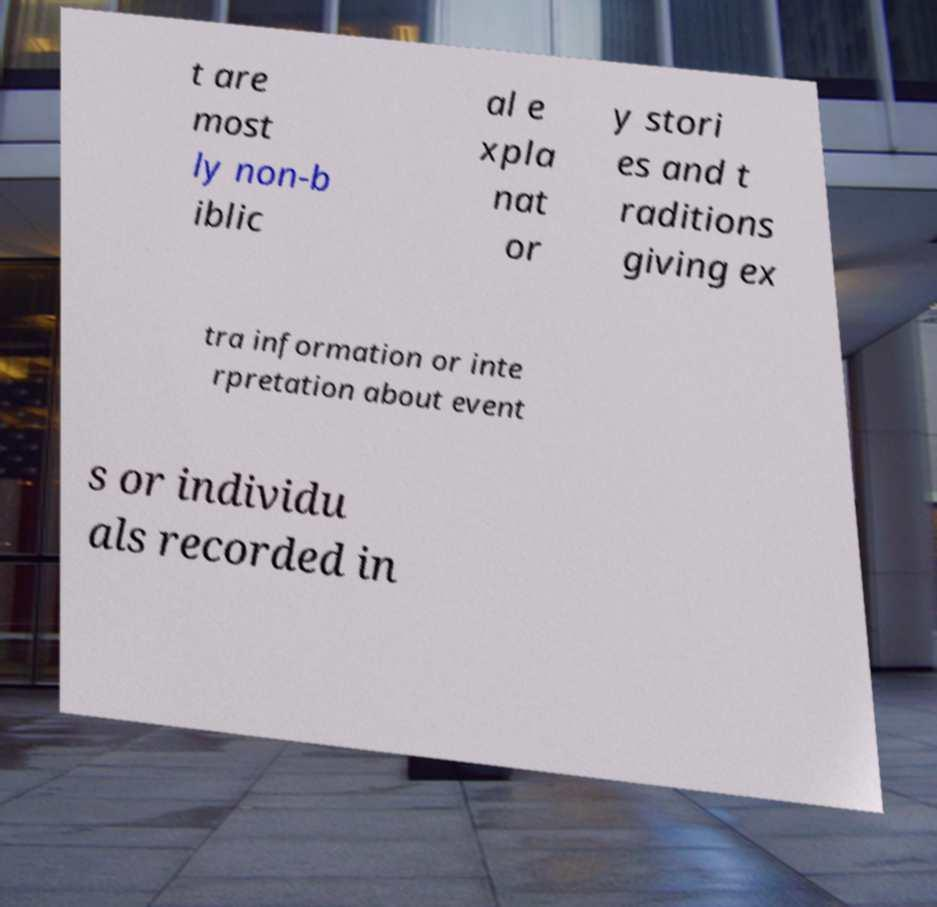Can you read and provide the text displayed in the image?This photo seems to have some interesting text. Can you extract and type it out for me? t are most ly non-b iblic al e xpla nat or y stori es and t raditions giving ex tra information or inte rpretation about event s or individu als recorded in 